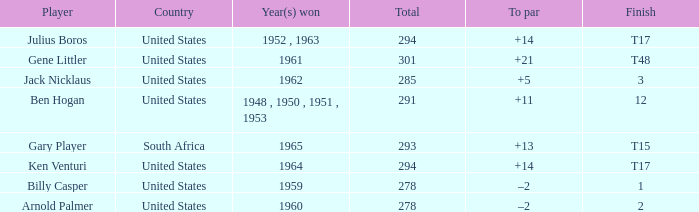What is Finish, when Country is "United States", and when To Par is "+21"? T48. 